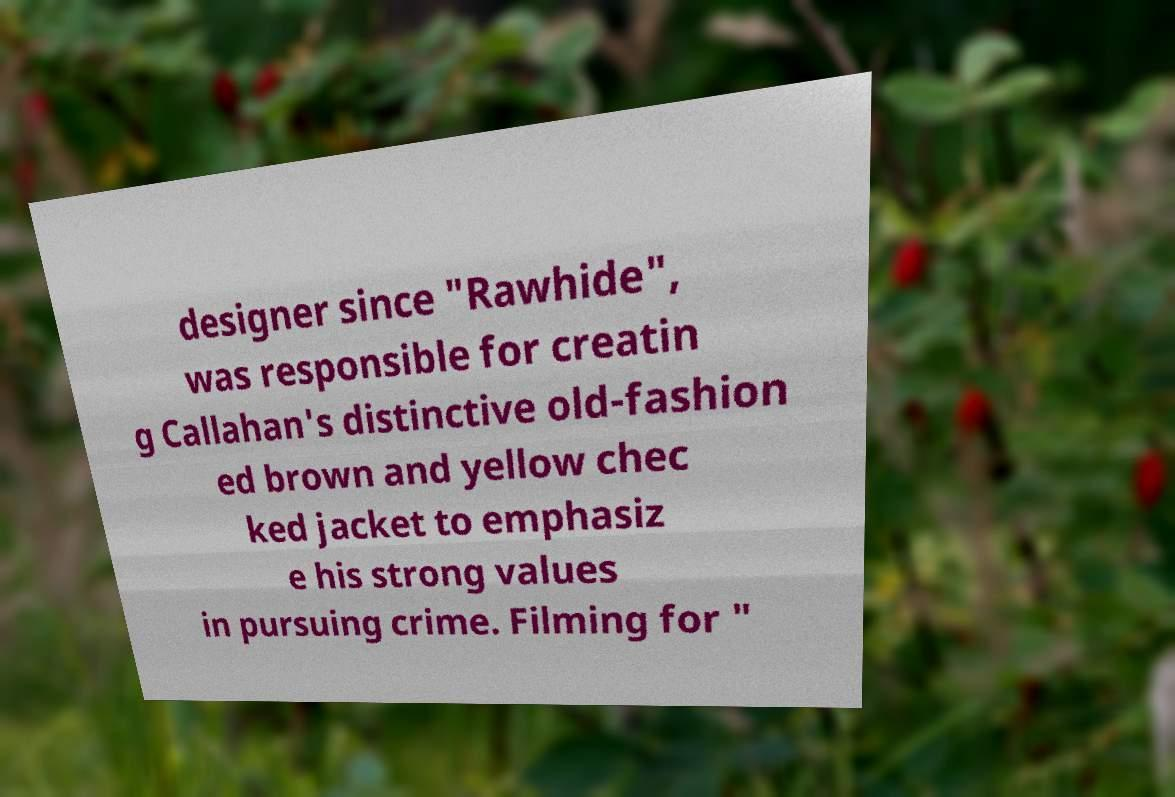I need the written content from this picture converted into text. Can you do that? designer since "Rawhide", was responsible for creatin g Callahan's distinctive old-fashion ed brown and yellow chec ked jacket to emphasiz e his strong values in pursuing crime. Filming for " 